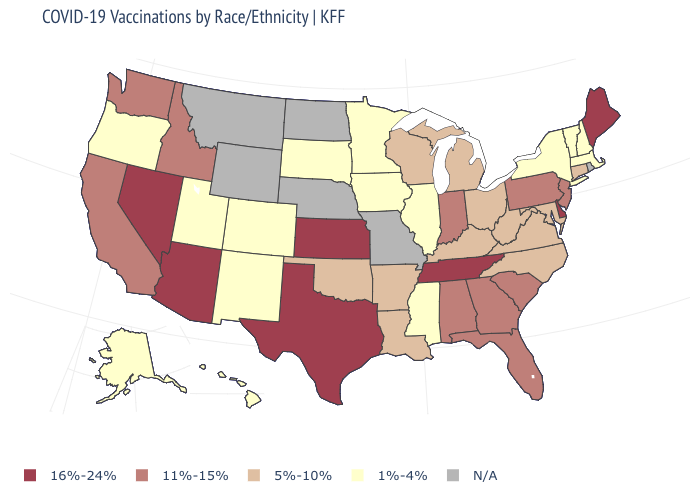Among the states that border Oregon , does Nevada have the highest value?
Give a very brief answer. Yes. Name the states that have a value in the range 16%-24%?
Give a very brief answer. Arizona, Delaware, Kansas, Maine, Nevada, Tennessee, Texas. What is the value of South Carolina?
Write a very short answer. 11%-15%. Among the states that border Massachusetts , which have the highest value?
Write a very short answer. Connecticut. Among the states that border Arkansas , which have the highest value?
Short answer required. Tennessee, Texas. What is the highest value in the USA?
Concise answer only. 16%-24%. Name the states that have a value in the range 1%-4%?
Short answer required. Alaska, Colorado, Hawaii, Illinois, Iowa, Massachusetts, Minnesota, Mississippi, New Hampshire, New Mexico, New York, Oregon, South Dakota, Utah, Vermont. Does Mississippi have the lowest value in the South?
Quick response, please. Yes. Name the states that have a value in the range 1%-4%?
Write a very short answer. Alaska, Colorado, Hawaii, Illinois, Iowa, Massachusetts, Minnesota, Mississippi, New Hampshire, New Mexico, New York, Oregon, South Dakota, Utah, Vermont. Which states have the highest value in the USA?
Write a very short answer. Arizona, Delaware, Kansas, Maine, Nevada, Tennessee, Texas. Does Delaware have the lowest value in the South?
Keep it brief. No. Does Massachusetts have the lowest value in the USA?
Write a very short answer. Yes. What is the lowest value in states that border Connecticut?
Give a very brief answer. 1%-4%. Which states have the lowest value in the MidWest?
Quick response, please. Illinois, Iowa, Minnesota, South Dakota. Name the states that have a value in the range N/A?
Concise answer only. Missouri, Montana, Nebraska, North Dakota, Rhode Island, Wyoming. 